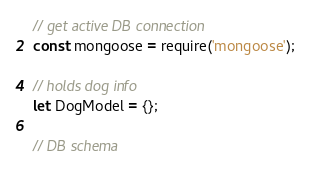<code> <loc_0><loc_0><loc_500><loc_500><_JavaScript_>// get active DB connection
const mongoose = require('mongoose');

// holds dog info
let DogModel = {};

// DB schema</code> 